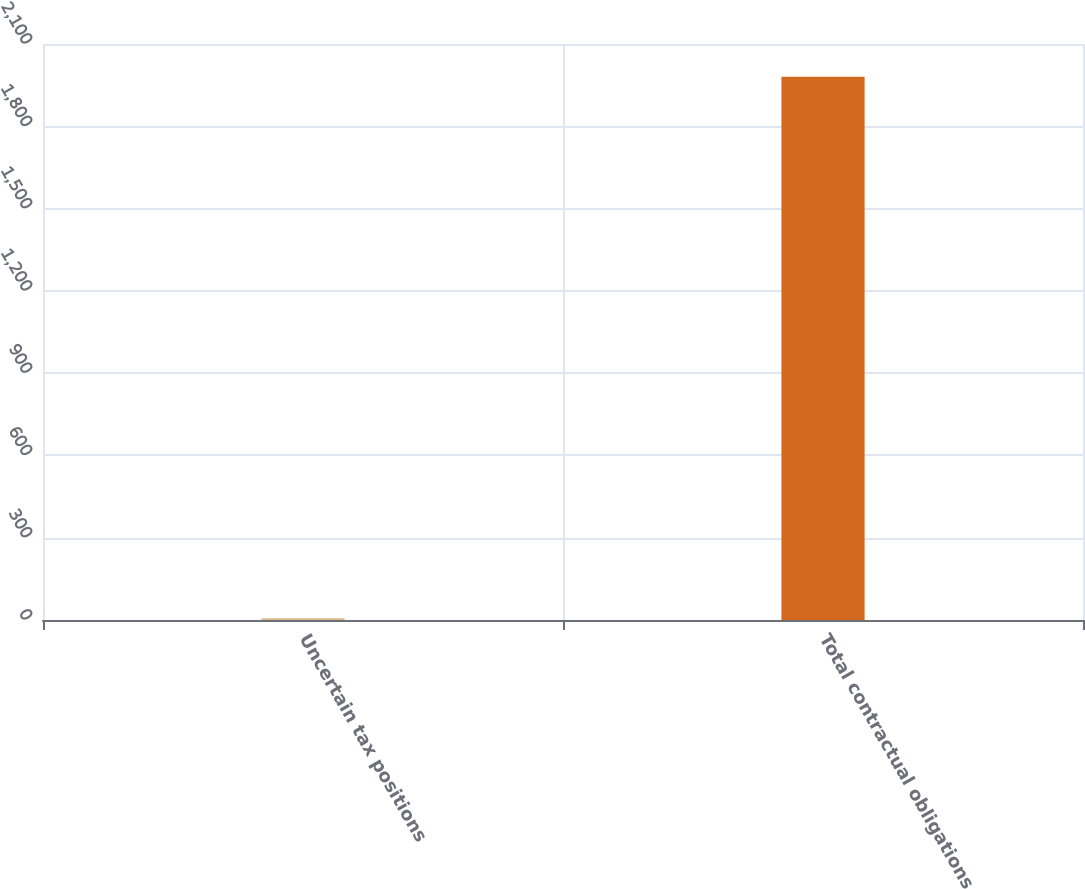Convert chart to OTSL. <chart><loc_0><loc_0><loc_500><loc_500><bar_chart><fcel>Uncertain tax positions<fcel>Total contractual obligations<nl><fcel>6.3<fcel>1980.8<nl></chart> 